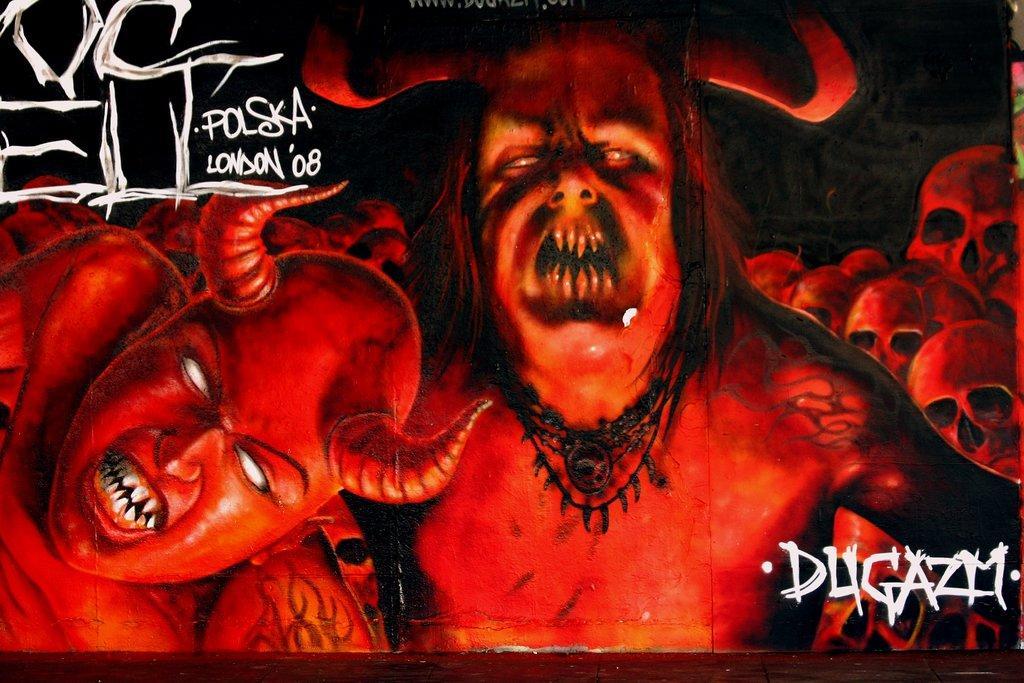How would you summarize this image in a sentence or two? In this image we can see a poster. There are images of monsters. Also something is written on the image. In the back there are skulls. 